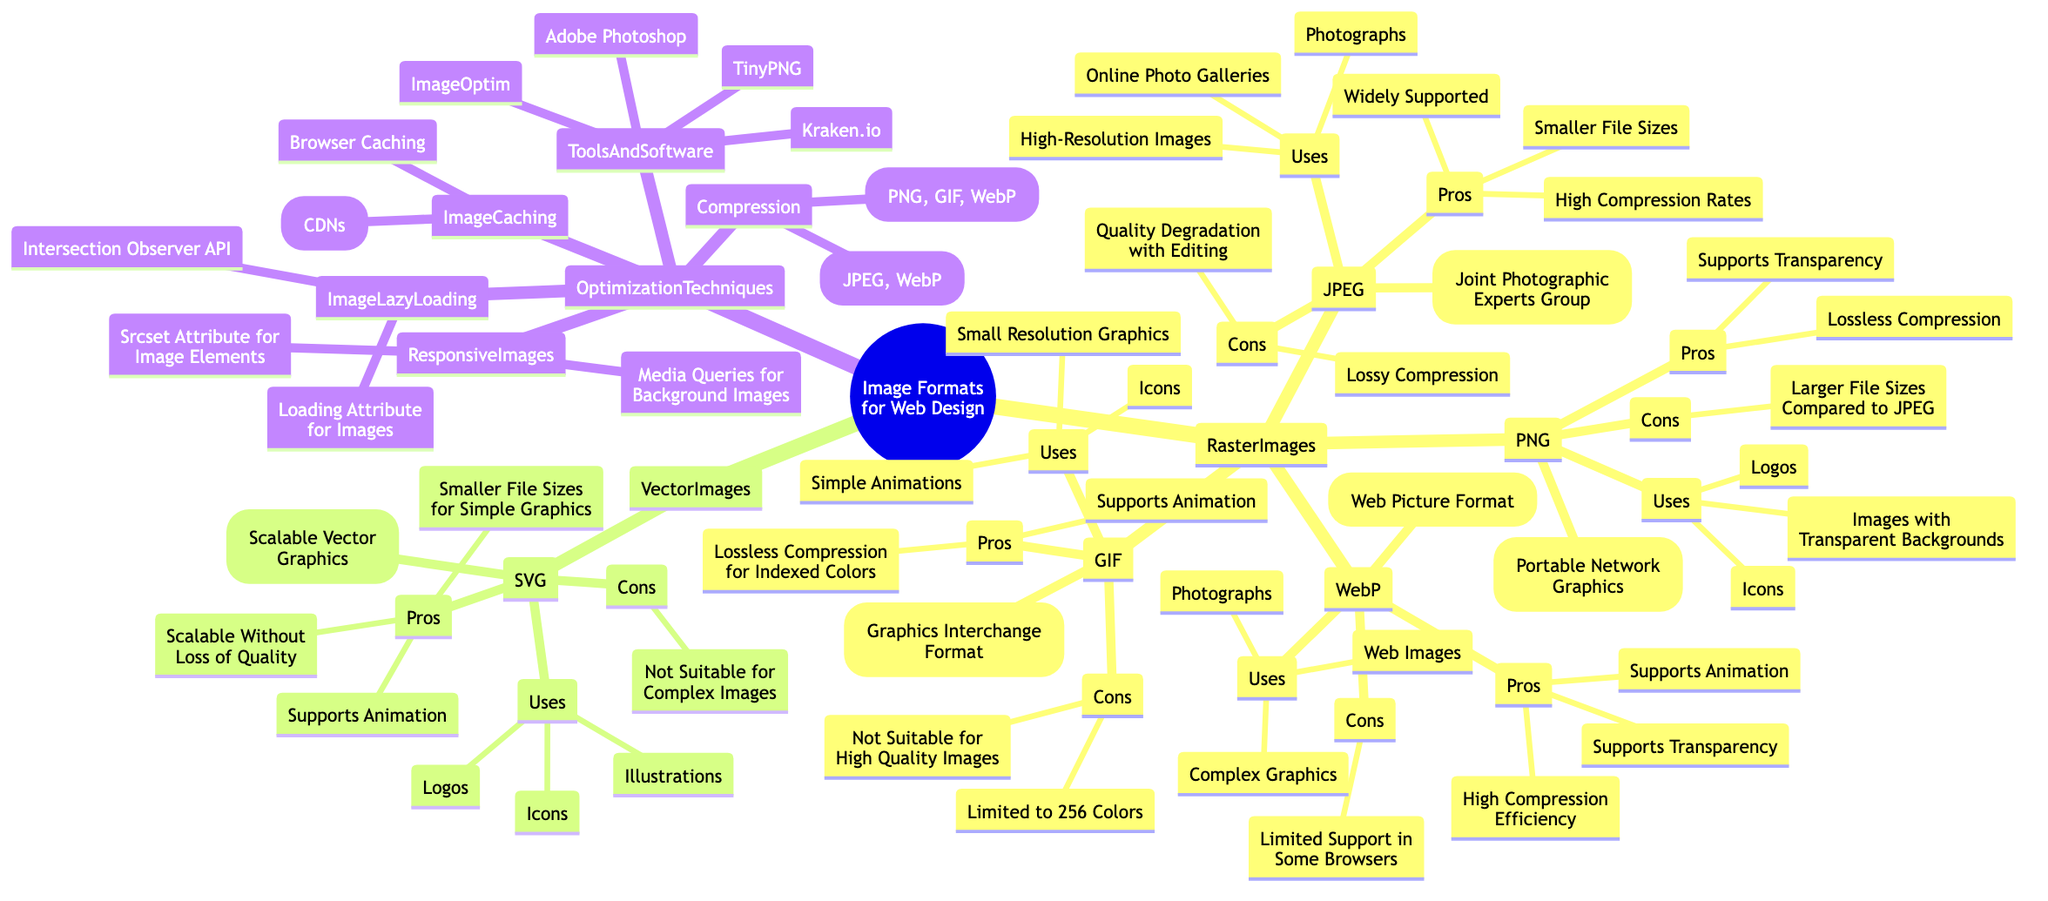What is the full form of JPEG? The diagram indicates that JPEG stands for Joint Photographic Experts Group, which is located under the JPEG format in the Raster Images category.
Answer: Joint Photographic Experts Group How many formats are listed under Raster Images? The diagram shows four formats under Raster Images: JPEG, PNG, GIF, and WebP. By counting these nodes, we confirm that there are a total of 4.
Answer: 4 What is one pro of using PNG? According to the diagram, one of the pros of using PNG is "Lossless Compression," which is listed under the PNG format node in Raster Images.
Answer: Lossless Compression Which image format supports animation? The diagram shows that both GIF and WebP formats support animation. This information can be found under their respective format nodes.
Answer: GIF and WebP What is a technique for optimizing images mentioned in the diagram? The diagram lists several optimization techniques, one of them being "Compression," which can be found under the Optimization Techniques category.
Answer: Compression What does SVG stand for? The diagram specifies that SVG stands for Scalable Vector Graphics, which is listed under the SVG format in the Vector Images category.
Answer: Scalable Vector Graphics What is a con of using GIF? According to the diagram, a con of using GIF is that it is "Limited to 256 Colors," which is directly stated under the GIF format node.
Answer: Limited to 256 Colors What type of images is WebP used for? The diagram states that WebP is used for "Web Images," "Photographs," and "Complex Graphics," all of which are listed under the WebP format node in Raster Images.
Answer: Web Images, Photographs, Complex Graphics What compression type is used for JPEG? The diagram shows that JPEG uses "Lossy Compression," which is included in the Compression techniques listed under Optimization Techniques.
Answer: Lossy Compression 